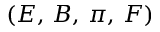Convert formula to latex. <formula><loc_0><loc_0><loc_500><loc_500>( E , \, B , \, \pi , \, F )</formula> 